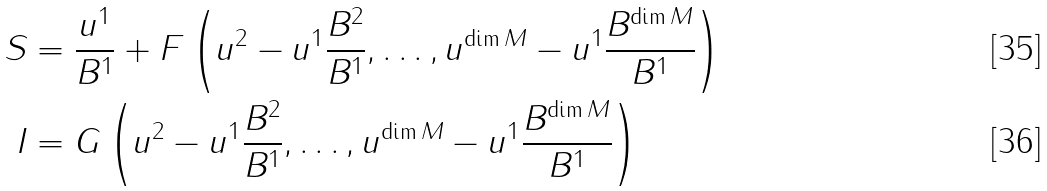<formula> <loc_0><loc_0><loc_500><loc_500>S & = \frac { u ^ { 1 } } { B ^ { 1 } } + F \left ( u ^ { 2 } - u ^ { 1 } \frac { B ^ { 2 } } { B ^ { 1 } } , \dots , u ^ { \dim M } - u ^ { 1 } \frac { B ^ { \dim M } } { B ^ { 1 } } \right ) \\ I & = G \left ( u ^ { 2 } - u ^ { 1 } \frac { B ^ { 2 } } { B ^ { 1 } } , \dots , u ^ { \dim M } - u ^ { 1 } \frac { B ^ { \dim M } } { B ^ { 1 } } \right )</formula> 